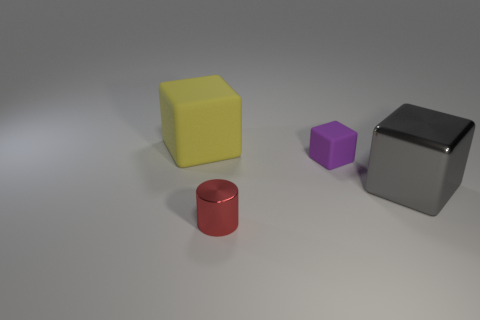What number of small purple objects are there?
Make the answer very short. 1. How many tiny objects are cyan matte cubes or gray shiny things?
Your answer should be very brief. 0. The yellow object that is the same size as the gray metal thing is what shape?
Your answer should be compact. Cube. Are there any other things that are the same size as the purple object?
Keep it short and to the point. Yes. There is a big cube left of the rubber thing that is in front of the large yellow thing; what is its material?
Ensure brevity in your answer.  Rubber. Does the yellow block have the same size as the gray shiny cube?
Your response must be concise. Yes. How many things are shiny things to the right of the small red thing or red metallic cylinders?
Your response must be concise. 2. There is a shiny object on the left side of the small object right of the red shiny thing; what shape is it?
Offer a very short reply. Cylinder. Does the yellow block have the same size as the matte cube right of the yellow rubber thing?
Your answer should be very brief. No. What is the block on the left side of the purple rubber thing made of?
Keep it short and to the point. Rubber. 